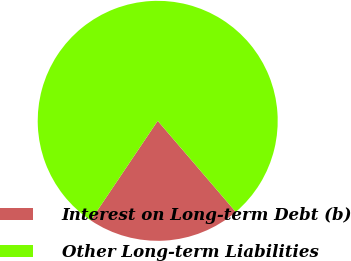Convert chart to OTSL. <chart><loc_0><loc_0><loc_500><loc_500><pie_chart><fcel>Interest on Long-term Debt (b)<fcel>Other Long-term Liabilities<nl><fcel>20.7%<fcel>79.3%<nl></chart> 